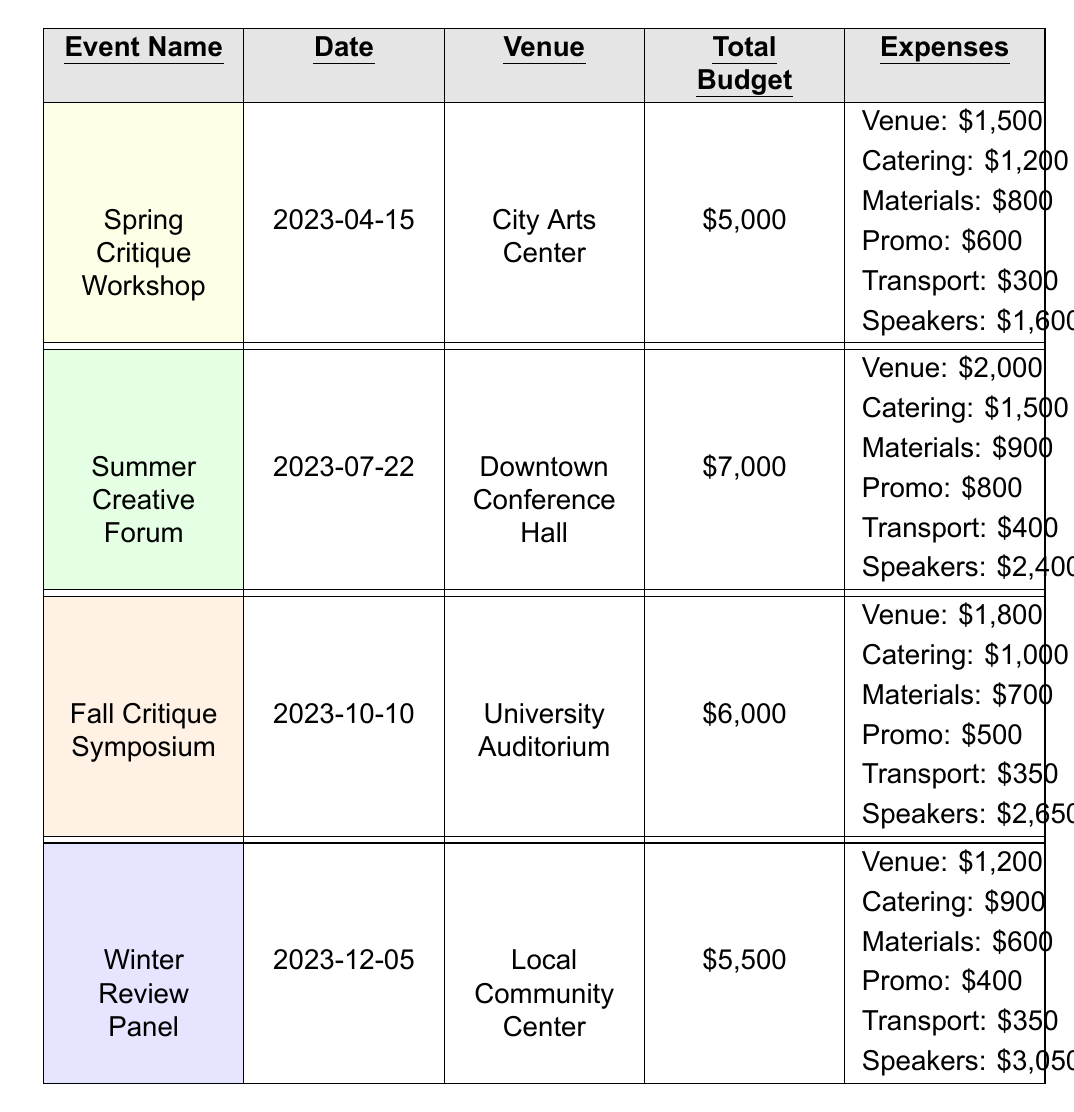What is the total budget for the Winter Review Panel? The table shows that the total budget for the Winter Review Panel is listed as \$5,500.
Answer: \$5,500 What is the date of the Summer Creative Forum? The table indicates that the Summer Creative Forum is scheduled for July 22, 2023.
Answer: July 22, 2023 Which event has the highest speaker fees? By looking at the expenses of each event, the highest speaker fees are for the Winter Review Panel at \$3,050.
Answer: Winter Review Panel What is the total amount spent on catering across all events? Summing the catering expenses: \$1,200 (Spring) + \$1,500 (Summer) + \$1,000 (Fall) + \$900 (Winter) yields \$4,600.
Answer: \$4,600 Is the total budget for the Fall Critique Symposium greater than 5,500? The total budget for the Fall Critique Symposium is \$6,000, which is greater than \$5,500.
Answer: Yes What is the difference in total budget between the Summer Creative Forum and the Fall Critique Symposium? The Summer Creative Forum has a total budget of \$7,000, and the Fall Critique Symposium has \$6,000. The difference is \$7,000 - \$6,000 = \$1,000.
Answer: \$1,000 What percentage of the total budget for the Spring Critique Workshop is allocated to speaker fees? The total budget for the Spring Critique Workshop is \$5,000, and the speaker fees are \$1,600. The percentage is calculated as (\$1,600 / \$5,000) * 100 = 32%.
Answer: 32% Which venue has the lowest rental cost among the events? By comparing the venue rental costs: \$1,500 (Spring), \$2,000 (Summer), \$1,800 (Fall), and \$1,200 (Winter), the lowest rental cost is \$1,200 for the Winter Review Panel.
Answer: Local Community Center What is the average total budget for all critique events? Adding the total budgets: \$5,000 (Spring) + \$7,000 (Summer) + \$6,000 (Fall) + \$5,500 (Winter) = \$23,500. Dividing by 4 events gives an average budget of \$23,500 / 4 = \$5,875.
Answer: \$5,875 Are there any events that have a total budget of \$6,000? The Fall Critique Symposium has a total budget listed as \$6,000.
Answer: Yes 